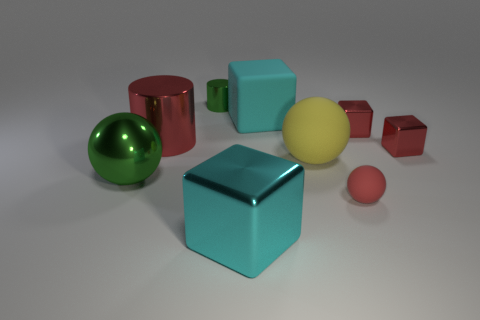How many small metallic cylinders are the same color as the large metal sphere?
Provide a short and direct response. 1. What material is the big cube that is in front of the matte object that is behind the big yellow object behind the cyan metal object?
Your response must be concise. Metal. What color is the big sphere that is to the left of the large block that is behind the big cyan metallic object?
Make the answer very short. Green. What number of tiny things are either yellow matte spheres or red spheres?
Your response must be concise. 1. How many large red objects have the same material as the small sphere?
Make the answer very short. 0. There is a green object that is left of the tiny green metallic object; what size is it?
Ensure brevity in your answer.  Large. There is a green object that is in front of the green thing that is right of the green ball; what shape is it?
Your answer should be very brief. Sphere. What number of big shiny cylinders are behind the green metal object behind the big cyan object behind the large red shiny object?
Your answer should be very brief. 0. Is the number of tiny green metal cylinders that are left of the big metallic sphere less than the number of large yellow objects?
Ensure brevity in your answer.  Yes. Are there any other things that have the same shape as the big red thing?
Your answer should be compact. Yes. 